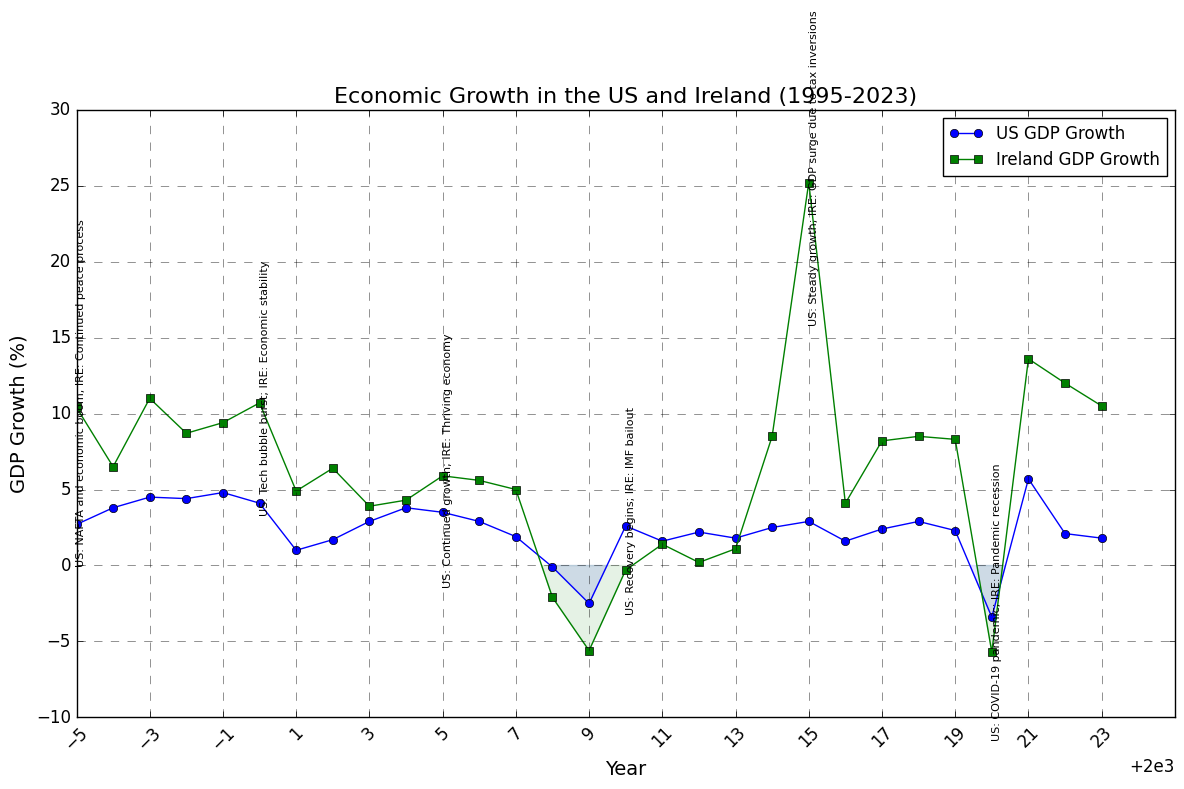What was the GDP growth for the US during the year of the 9/11 attacks? Locate the year 2001 in the chart and look at the corresponding US GDP growth value
Answer: 1.0 Between 2013 and 2014, which country experienced a greater increase in GDP growth, and by how much? Look at the GDP growth values for both countries in 2013 and 2014. The US growth went from 1.8% to 2.5% (an increase of 0.7%), while Ireland's growth went from 1.1% to 8.5% (an increase of 7.4%). Compare the increases.
Answer: Ireland, by 6.7% Identify a period when Ireland's GDP growth was negative and compare it to the corresponding US GDP growth in the same period. Notice Ireland’s GDP growth was negative from 2008 to 2010. In 2008, Ireland's GDP growth was -2.1% and the US's was -0.1%. In 2009, Ireland's was -5.6% and the US's was -2.5%. In 2010, Ireland's was -0.3% and the US's was 2.6%.
Answer: 2008: US (-0.1%), Ireland (-2.1%); 2009: US (-2.5%), Ireland (-5.6%); 2010: US (2.6%), Ireland (-0.3%) What was the impact of the COVID-19 pandemic on the GDP growth of the US and Ireland in 2020? Locate the year 2020 on the chart and observe the GDP growth values for both countries. The US GDP growth was -3.4%, and Ireland's GDP growth was -5.7%.
Answer: US: -3.4%, Ireland: -5.7% How did the GDP growth rates in the US and Ireland differ in 2015, and what major political event is associated with Ireland in that year? Check the GDP growth rates for both countries in 2015. The US had a 2.9% growth rate, while Ireland had a 25.2% growth rate due to tax inversions.
Answer: US: 2.9%, Ireland: 25.2%; event: GDP surge due to tax inversions 